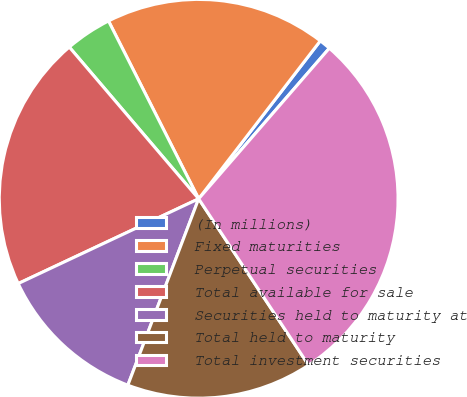Convert chart to OTSL. <chart><loc_0><loc_0><loc_500><loc_500><pie_chart><fcel>(In millions)<fcel>Fixed maturities<fcel>Perpetual securities<fcel>Total available for sale<fcel>Securities held to maturity at<fcel>Total held to maturity<fcel>Total investment securities<nl><fcel>0.93%<fcel>17.91%<fcel>3.77%<fcel>20.75%<fcel>12.23%<fcel>15.07%<fcel>29.33%<nl></chart> 